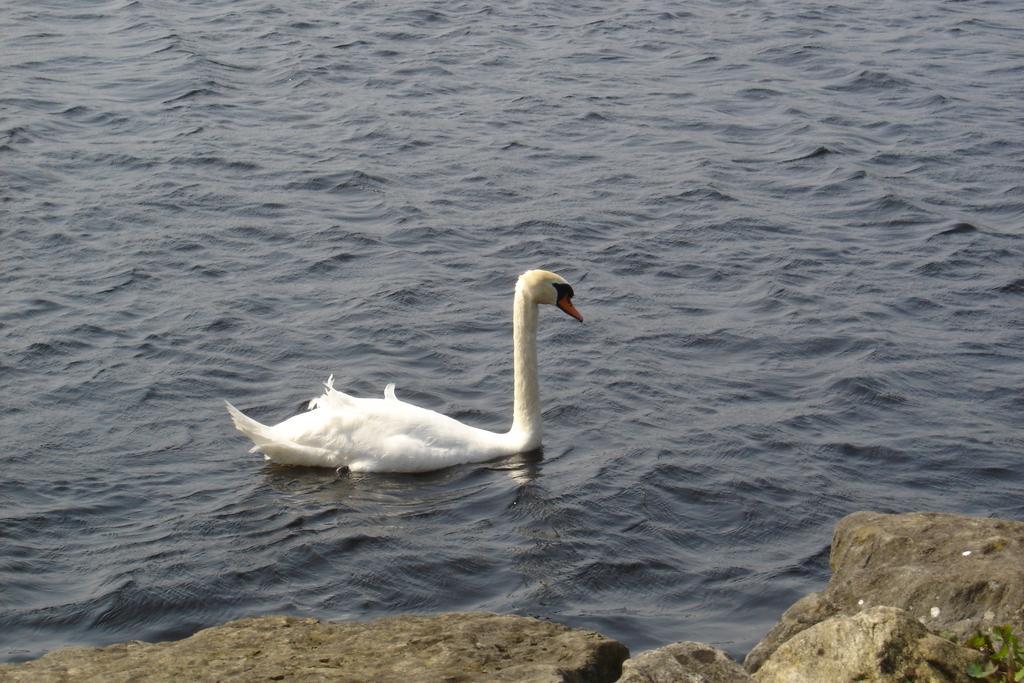In one or two sentences, can you explain what this image depicts? In the image we can see there is a swan swimming in the water and there are rocks. 